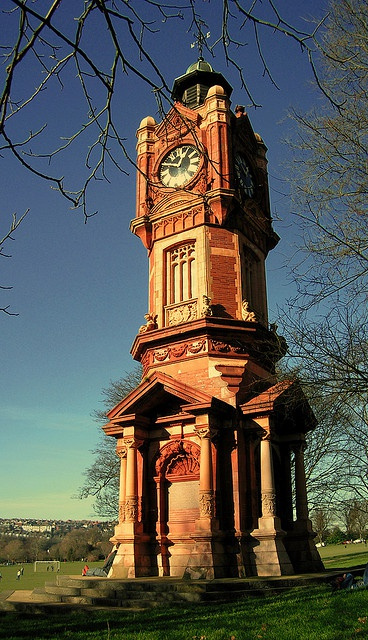Describe the objects in this image and their specific colors. I can see clock in darkblue, khaki, gray, tan, and olive tones, clock in darkblue, black, darkgreen, and gray tones, people in darkblue, darkgreen, black, gray, and olive tones, people in darkblue, black, navy, and teal tones, and car in darkblue, khaki, maroon, black, and darkgreen tones in this image. 